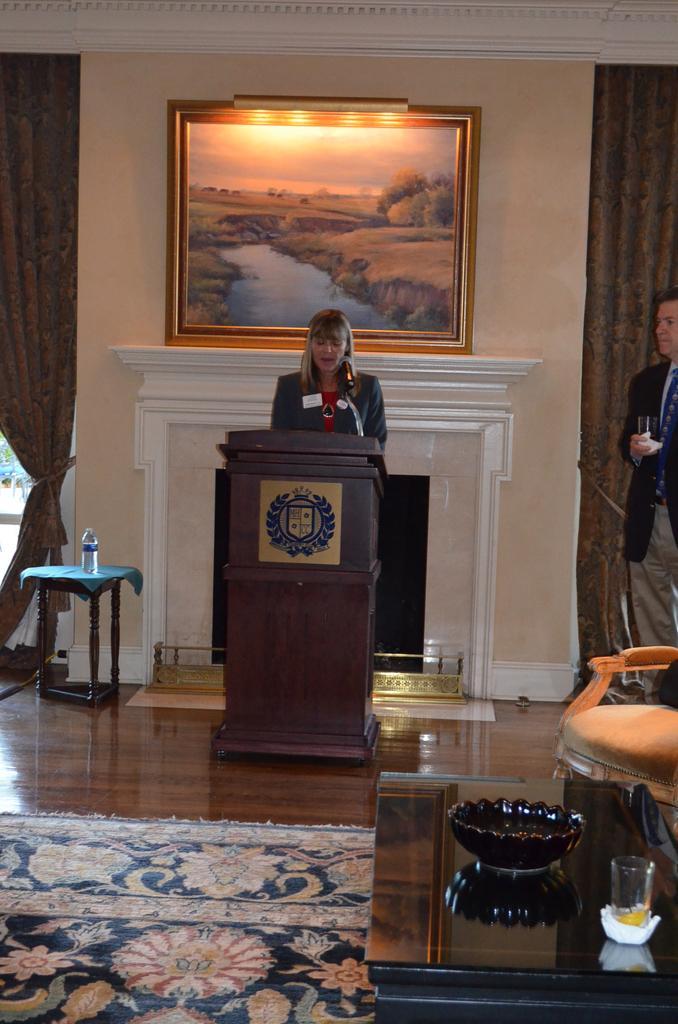Can you describe this image briefly? Here we can see a woman speaking into microphones present on the speech desk in front of her and beside her we can see a table and a bottle of water present and behind her we can see a portrait present and at the right side we can see a person standing 